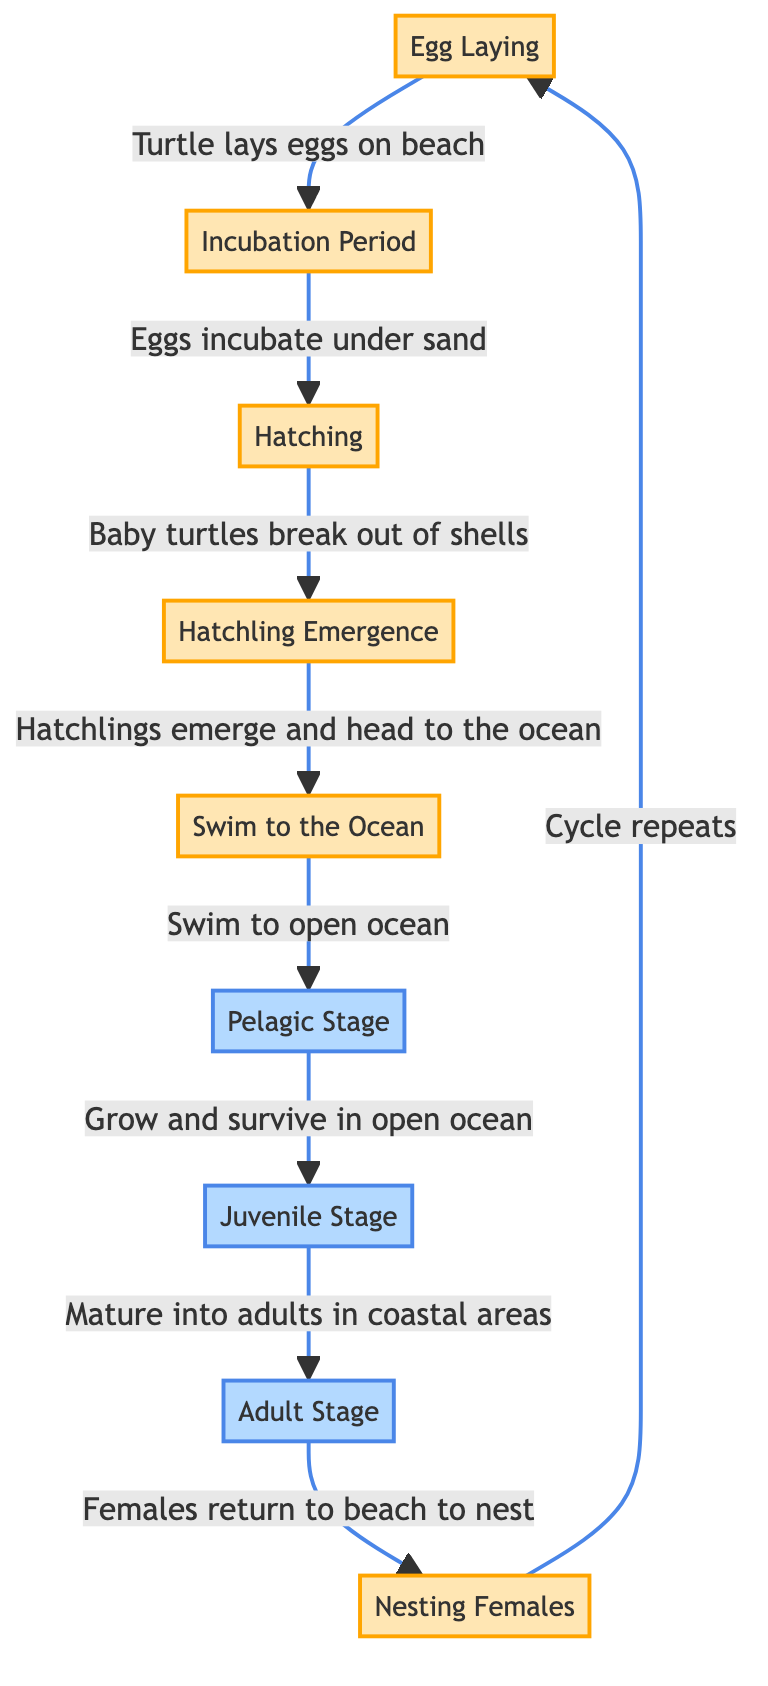What is the first step in the lifecycle of a marine turtle? The first step is represented by the "Egg Laying" node in the diagram, which shows the initial action where the turtle lays eggs on the beach.
Answer: Egg Laying How many stages are there before a turtle reaches adulthood? The stages before adulthood are "Pelagic Stage" and "Juvenile Stage," leading to "Adult Stage." Counting these stages gives us three phases: pelagic stage, juvenile stage, and adult stage.
Answer: Three What happens after "Hatchling Emergence"? Following "Hatchling Emergence," the next step is "Hatchling Swim" where hatchlings swim to the ocean, as indicated by the directed arrow from one stage to the next.
Answer: Hatchling Swim What do female turtles do after becoming adults? The diagram shows that after reaching the "Adult Stage," females return to the beach to nest, indicated by the directed edge leading from "Adult Stage" to "Nesting Females."
Answer: Return to beach to nest What is the relationship between "Nesting Females" and "Egg Laying"? The diagram indicates a cyclical relationship where "Nesting Females" leads back to "Egg Laying," highlighting that females lay eggs as part of their nesting behavior.
Answer: Cycle repeats In what environment do turtles survive during their "Pelagic Stage"? The "Pelagic Stage" refers to the open ocean environment where turtles grow and survive after leaving the beach and swimming to the ocean.
Answer: Open ocean What is the last stage in the lifecycle of a marine turtle? The final stage is represented by the "Adult Stage," which indicates that the marine turtle has reached maturity.
Answer: Adult Stage How many total nodes are there in the lifecycle diagram? Counting all the nodes in the diagram, including stages like "Egg Laying," "Incubation Period," and others, results in a total of eight distinct stages or nodes.
Answer: Eight What indicates the direction of development in this lifecycle? The arrows in the diagram indicate the direction of development, showing how each stage progresses to the next through directed edges.
Answer: Arrows 